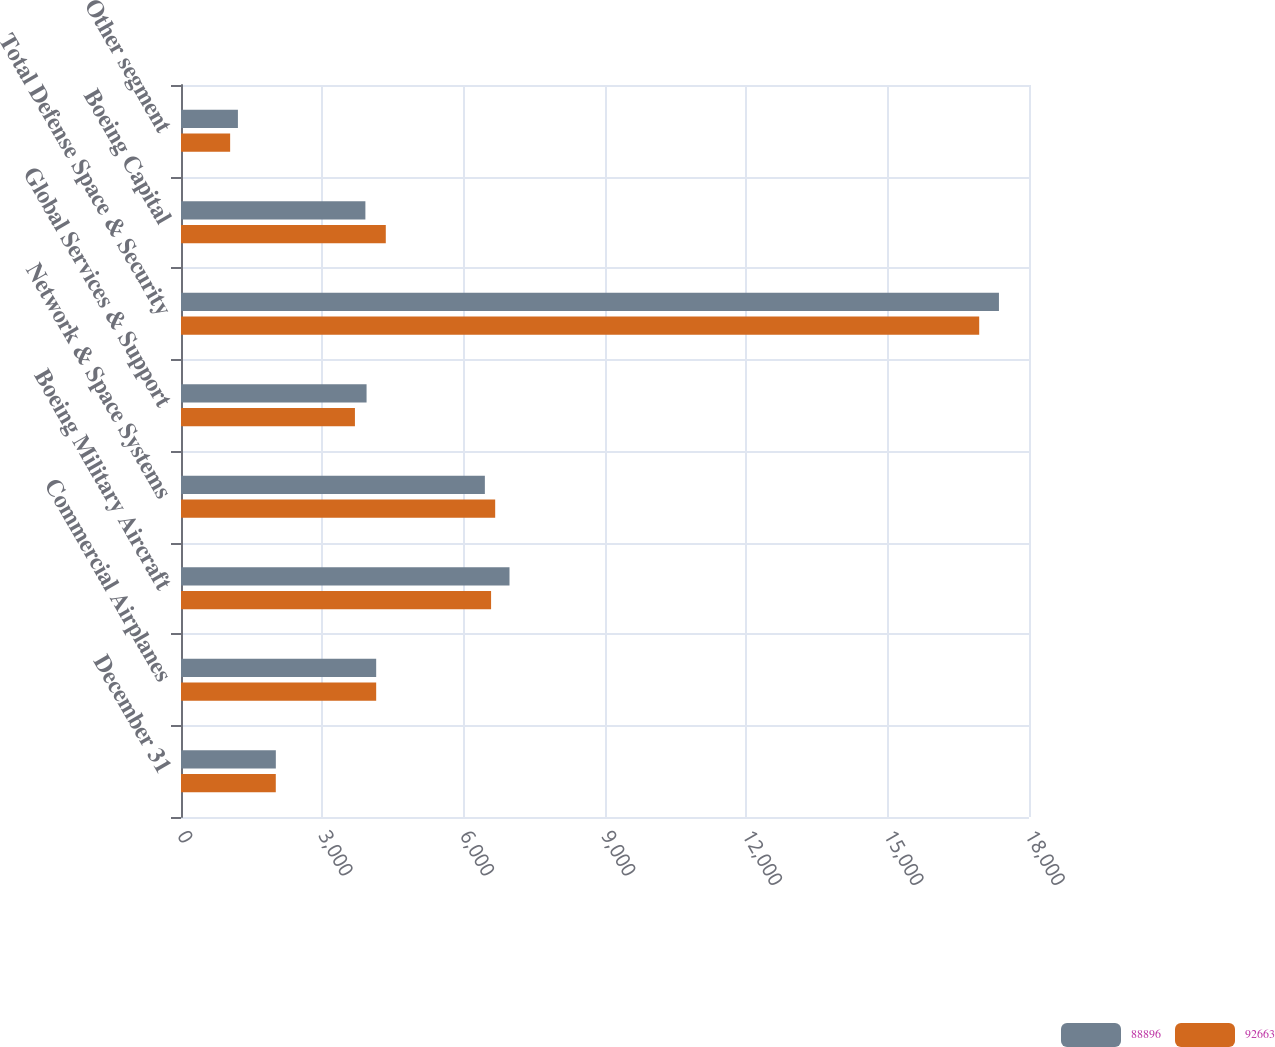Convert chart. <chart><loc_0><loc_0><loc_500><loc_500><stacked_bar_chart><ecel><fcel>December 31<fcel>Commercial Airplanes<fcel>Boeing Military Aircraft<fcel>Network & Space Systems<fcel>Global Services & Support<fcel>Total Defense Space & Security<fcel>Boeing Capital<fcel>Other segment<nl><fcel>88896<fcel>2013<fcel>4143<fcel>6973<fcel>6450<fcel>3939<fcel>17362<fcel>3914<fcel>1208<nl><fcel>92663<fcel>2012<fcel>4143<fcel>6582<fcel>6669<fcel>3692<fcel>16943<fcel>4347<fcel>1043<nl></chart> 